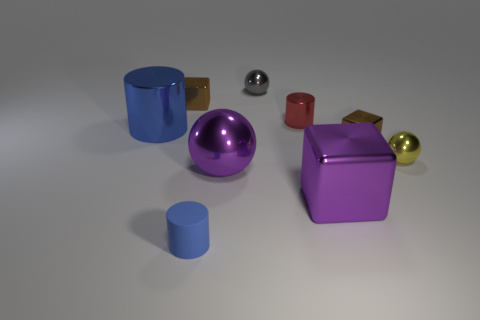Is the material of the gray object the same as the yellow object?
Your response must be concise. Yes. What is the color of the cylinder in front of the brown metallic block right of the tiny blue cylinder?
Offer a very short reply. Blue. There is another red object that is the same shape as the rubber thing; what size is it?
Offer a terse response. Small. Does the big ball have the same color as the tiny matte object?
Make the answer very short. No. There is a big purple metallic ball that is in front of the small ball that is behind the small yellow ball; what number of big shiny spheres are on the right side of it?
Your response must be concise. 0. Is the number of gray shiny objects greater than the number of small brown rubber cylinders?
Give a very brief answer. Yes. What number of gray balls are there?
Your answer should be very brief. 1. What shape is the tiny brown object that is on the left side of the brown object that is in front of the blue cylinder behind the tiny matte thing?
Your answer should be compact. Cube. Is the number of brown metal blocks behind the small blue rubber cylinder less than the number of large things that are in front of the gray metallic sphere?
Offer a terse response. Yes. Does the big purple thing that is in front of the big sphere have the same shape as the yellow object right of the small red metallic cylinder?
Provide a short and direct response. No. 